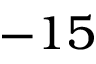Convert formula to latex. <formula><loc_0><loc_0><loc_500><loc_500>- 1 5</formula> 